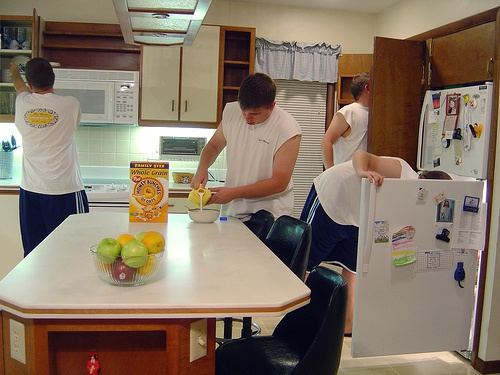Describe the objects in this image and their specific colors. I can see refrigerator in olive, darkgray, and gray tones, dining table in olive, tan, darkgray, beige, and lightgray tones, people in olive, darkgray, brown, and black tones, people in olive, darkgray, black, and lightgray tones, and people in olive, black, darkgray, brown, and gray tones in this image. 